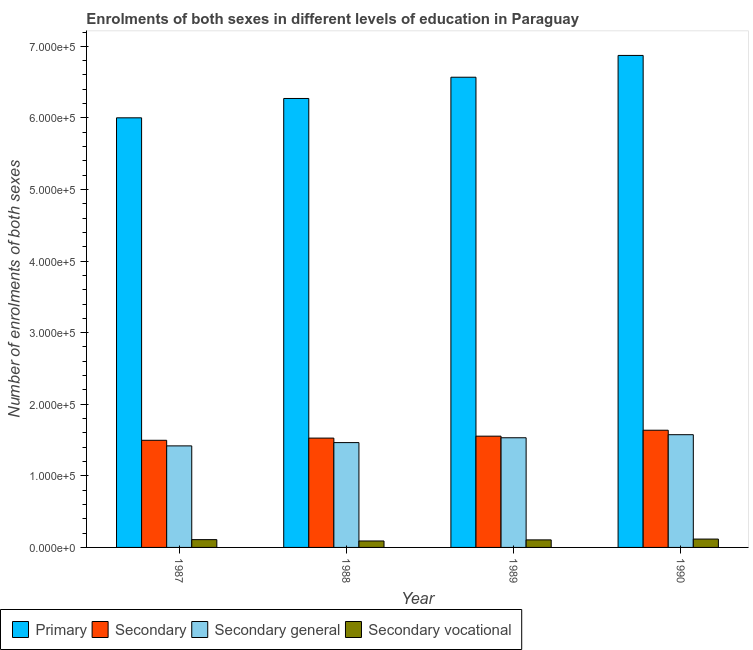How many different coloured bars are there?
Provide a succinct answer. 4. How many groups of bars are there?
Make the answer very short. 4. Are the number of bars per tick equal to the number of legend labels?
Your response must be concise. Yes. What is the label of the 1st group of bars from the left?
Make the answer very short. 1987. What is the number of enrolments in secondary vocational education in 1989?
Give a very brief answer. 1.05e+04. Across all years, what is the maximum number of enrolments in secondary general education?
Ensure brevity in your answer.  1.57e+05. Across all years, what is the minimum number of enrolments in secondary education?
Give a very brief answer. 1.50e+05. In which year was the number of enrolments in primary education maximum?
Ensure brevity in your answer.  1990. In which year was the number of enrolments in primary education minimum?
Offer a very short reply. 1987. What is the total number of enrolments in primary education in the graph?
Your answer should be very brief. 2.57e+06. What is the difference between the number of enrolments in secondary vocational education in 1989 and that in 1990?
Provide a short and direct response. -1152. What is the difference between the number of enrolments in secondary vocational education in 1988 and the number of enrolments in secondary education in 1990?
Your response must be concise. -2680. What is the average number of enrolments in secondary general education per year?
Offer a terse response. 1.50e+05. In the year 1990, what is the difference between the number of enrolments in secondary general education and number of enrolments in primary education?
Give a very brief answer. 0. What is the ratio of the number of enrolments in secondary general education in 1987 to that in 1989?
Your answer should be compact. 0.93. Is the number of enrolments in secondary vocational education in 1988 less than that in 1989?
Your answer should be very brief. Yes. Is the difference between the number of enrolments in secondary general education in 1987 and 1990 greater than the difference between the number of enrolments in secondary vocational education in 1987 and 1990?
Your answer should be very brief. No. What is the difference between the highest and the second highest number of enrolments in secondary vocational education?
Offer a terse response. 803. What is the difference between the highest and the lowest number of enrolments in primary education?
Ensure brevity in your answer.  8.72e+04. In how many years, is the number of enrolments in primary education greater than the average number of enrolments in primary education taken over all years?
Provide a short and direct response. 2. Is the sum of the number of enrolments in secondary general education in 1987 and 1989 greater than the maximum number of enrolments in secondary education across all years?
Offer a terse response. Yes. What does the 2nd bar from the left in 1989 represents?
Your response must be concise. Secondary. What does the 4th bar from the right in 1989 represents?
Offer a very short reply. Primary. Is it the case that in every year, the sum of the number of enrolments in primary education and number of enrolments in secondary education is greater than the number of enrolments in secondary general education?
Your answer should be very brief. Yes. How many bars are there?
Your response must be concise. 16. Are all the bars in the graph horizontal?
Your answer should be very brief. No. What is the difference between two consecutive major ticks on the Y-axis?
Offer a very short reply. 1.00e+05. Does the graph contain grids?
Your answer should be compact. No. How many legend labels are there?
Provide a succinct answer. 4. How are the legend labels stacked?
Your response must be concise. Horizontal. What is the title of the graph?
Provide a succinct answer. Enrolments of both sexes in different levels of education in Paraguay. What is the label or title of the Y-axis?
Give a very brief answer. Number of enrolments of both sexes. What is the Number of enrolments of both sexes in Primary in 1987?
Your response must be concise. 6.00e+05. What is the Number of enrolments of both sexes of Secondary in 1987?
Offer a very short reply. 1.50e+05. What is the Number of enrolments of both sexes of Secondary general in 1987?
Offer a very short reply. 1.42e+05. What is the Number of enrolments of both sexes in Secondary vocational in 1987?
Give a very brief answer. 1.09e+04. What is the Number of enrolments of both sexes in Primary in 1988?
Ensure brevity in your answer.  6.27e+05. What is the Number of enrolments of both sexes in Secondary in 1988?
Give a very brief answer. 1.53e+05. What is the Number of enrolments of both sexes in Secondary general in 1988?
Your answer should be compact. 1.46e+05. What is the Number of enrolments of both sexes in Secondary vocational in 1988?
Provide a short and direct response. 9000. What is the Number of enrolments of both sexes of Primary in 1989?
Your answer should be compact. 6.57e+05. What is the Number of enrolments of both sexes of Secondary in 1989?
Your answer should be very brief. 1.55e+05. What is the Number of enrolments of both sexes of Secondary general in 1989?
Offer a very short reply. 1.53e+05. What is the Number of enrolments of both sexes of Secondary vocational in 1989?
Ensure brevity in your answer.  1.05e+04. What is the Number of enrolments of both sexes of Primary in 1990?
Ensure brevity in your answer.  6.87e+05. What is the Number of enrolments of both sexes in Secondary in 1990?
Offer a terse response. 1.64e+05. What is the Number of enrolments of both sexes of Secondary general in 1990?
Your answer should be compact. 1.57e+05. What is the Number of enrolments of both sexes of Secondary vocational in 1990?
Provide a succinct answer. 1.17e+04. Across all years, what is the maximum Number of enrolments of both sexes in Primary?
Your answer should be compact. 6.87e+05. Across all years, what is the maximum Number of enrolments of both sexes in Secondary?
Ensure brevity in your answer.  1.64e+05. Across all years, what is the maximum Number of enrolments of both sexes of Secondary general?
Your answer should be compact. 1.57e+05. Across all years, what is the maximum Number of enrolments of both sexes in Secondary vocational?
Your answer should be compact. 1.17e+04. Across all years, what is the minimum Number of enrolments of both sexes in Primary?
Offer a terse response. 6.00e+05. Across all years, what is the minimum Number of enrolments of both sexes in Secondary?
Your answer should be compact. 1.50e+05. Across all years, what is the minimum Number of enrolments of both sexes of Secondary general?
Your answer should be very brief. 1.42e+05. Across all years, what is the minimum Number of enrolments of both sexes of Secondary vocational?
Provide a succinct answer. 9000. What is the total Number of enrolments of both sexes of Primary in the graph?
Provide a short and direct response. 2.57e+06. What is the total Number of enrolments of both sexes of Secondary in the graph?
Offer a terse response. 6.22e+05. What is the total Number of enrolments of both sexes in Secondary general in the graph?
Keep it short and to the point. 5.99e+05. What is the total Number of enrolments of both sexes of Secondary vocational in the graph?
Your answer should be compact. 4.21e+04. What is the difference between the Number of enrolments of both sexes of Primary in 1987 and that in 1988?
Provide a short and direct response. -2.70e+04. What is the difference between the Number of enrolments of both sexes of Secondary in 1987 and that in 1988?
Make the answer very short. -3051. What is the difference between the Number of enrolments of both sexes of Secondary general in 1987 and that in 1988?
Offer a very short reply. -4584. What is the difference between the Number of enrolments of both sexes of Secondary vocational in 1987 and that in 1988?
Give a very brief answer. 1877. What is the difference between the Number of enrolments of both sexes in Primary in 1987 and that in 1989?
Provide a succinct answer. -5.67e+04. What is the difference between the Number of enrolments of both sexes in Secondary in 1987 and that in 1989?
Provide a short and direct response. -5758. What is the difference between the Number of enrolments of both sexes of Secondary general in 1987 and that in 1989?
Provide a short and direct response. -1.14e+04. What is the difference between the Number of enrolments of both sexes of Secondary vocational in 1987 and that in 1989?
Your answer should be very brief. 349. What is the difference between the Number of enrolments of both sexes of Primary in 1987 and that in 1990?
Your answer should be very brief. -8.72e+04. What is the difference between the Number of enrolments of both sexes in Secondary in 1987 and that in 1990?
Give a very brief answer. -1.41e+04. What is the difference between the Number of enrolments of both sexes in Secondary general in 1987 and that in 1990?
Give a very brief answer. -1.56e+04. What is the difference between the Number of enrolments of both sexes of Secondary vocational in 1987 and that in 1990?
Your answer should be compact. -803. What is the difference between the Number of enrolments of both sexes of Primary in 1988 and that in 1989?
Offer a very short reply. -2.97e+04. What is the difference between the Number of enrolments of both sexes in Secondary in 1988 and that in 1989?
Your response must be concise. -2707. What is the difference between the Number of enrolments of both sexes in Secondary general in 1988 and that in 1989?
Keep it short and to the point. -6772. What is the difference between the Number of enrolments of both sexes in Secondary vocational in 1988 and that in 1989?
Give a very brief answer. -1528. What is the difference between the Number of enrolments of both sexes in Primary in 1988 and that in 1990?
Offer a very short reply. -6.01e+04. What is the difference between the Number of enrolments of both sexes of Secondary in 1988 and that in 1990?
Ensure brevity in your answer.  -1.10e+04. What is the difference between the Number of enrolments of both sexes of Secondary general in 1988 and that in 1990?
Your answer should be compact. -1.11e+04. What is the difference between the Number of enrolments of both sexes of Secondary vocational in 1988 and that in 1990?
Keep it short and to the point. -2680. What is the difference between the Number of enrolments of both sexes of Primary in 1989 and that in 1990?
Your answer should be very brief. -3.05e+04. What is the difference between the Number of enrolments of both sexes in Secondary in 1989 and that in 1990?
Your answer should be very brief. -8300. What is the difference between the Number of enrolments of both sexes in Secondary general in 1989 and that in 1990?
Your answer should be very brief. -4281. What is the difference between the Number of enrolments of both sexes in Secondary vocational in 1989 and that in 1990?
Make the answer very short. -1152. What is the difference between the Number of enrolments of both sexes of Primary in 1987 and the Number of enrolments of both sexes of Secondary in 1988?
Your answer should be compact. 4.47e+05. What is the difference between the Number of enrolments of both sexes of Primary in 1987 and the Number of enrolments of both sexes of Secondary general in 1988?
Your answer should be compact. 4.54e+05. What is the difference between the Number of enrolments of both sexes of Primary in 1987 and the Number of enrolments of both sexes of Secondary vocational in 1988?
Make the answer very short. 5.91e+05. What is the difference between the Number of enrolments of both sexes of Secondary in 1987 and the Number of enrolments of both sexes of Secondary general in 1988?
Ensure brevity in your answer.  3242. What is the difference between the Number of enrolments of both sexes of Secondary in 1987 and the Number of enrolments of both sexes of Secondary vocational in 1988?
Your response must be concise. 1.41e+05. What is the difference between the Number of enrolments of both sexes in Secondary general in 1987 and the Number of enrolments of both sexes in Secondary vocational in 1988?
Your answer should be compact. 1.33e+05. What is the difference between the Number of enrolments of both sexes in Primary in 1987 and the Number of enrolments of both sexes in Secondary in 1989?
Your answer should be compact. 4.45e+05. What is the difference between the Number of enrolments of both sexes of Primary in 1987 and the Number of enrolments of both sexes of Secondary general in 1989?
Provide a succinct answer. 4.47e+05. What is the difference between the Number of enrolments of both sexes of Primary in 1987 and the Number of enrolments of both sexes of Secondary vocational in 1989?
Your answer should be very brief. 5.90e+05. What is the difference between the Number of enrolments of both sexes in Secondary in 1987 and the Number of enrolments of both sexes in Secondary general in 1989?
Offer a terse response. -3530. What is the difference between the Number of enrolments of both sexes in Secondary in 1987 and the Number of enrolments of both sexes in Secondary vocational in 1989?
Offer a very short reply. 1.39e+05. What is the difference between the Number of enrolments of both sexes of Secondary general in 1987 and the Number of enrolments of both sexes of Secondary vocational in 1989?
Give a very brief answer. 1.31e+05. What is the difference between the Number of enrolments of both sexes in Primary in 1987 and the Number of enrolments of both sexes in Secondary in 1990?
Ensure brevity in your answer.  4.36e+05. What is the difference between the Number of enrolments of both sexes of Primary in 1987 and the Number of enrolments of both sexes of Secondary general in 1990?
Provide a short and direct response. 4.43e+05. What is the difference between the Number of enrolments of both sexes in Primary in 1987 and the Number of enrolments of both sexes in Secondary vocational in 1990?
Make the answer very short. 5.88e+05. What is the difference between the Number of enrolments of both sexes of Secondary in 1987 and the Number of enrolments of both sexes of Secondary general in 1990?
Offer a terse response. -7811. What is the difference between the Number of enrolments of both sexes in Secondary in 1987 and the Number of enrolments of both sexes in Secondary vocational in 1990?
Your answer should be very brief. 1.38e+05. What is the difference between the Number of enrolments of both sexes of Secondary general in 1987 and the Number of enrolments of both sexes of Secondary vocational in 1990?
Your response must be concise. 1.30e+05. What is the difference between the Number of enrolments of both sexes in Primary in 1988 and the Number of enrolments of both sexes in Secondary in 1989?
Provide a short and direct response. 4.72e+05. What is the difference between the Number of enrolments of both sexes of Primary in 1988 and the Number of enrolments of both sexes of Secondary general in 1989?
Give a very brief answer. 4.74e+05. What is the difference between the Number of enrolments of both sexes of Primary in 1988 and the Number of enrolments of both sexes of Secondary vocational in 1989?
Offer a terse response. 6.17e+05. What is the difference between the Number of enrolments of both sexes in Secondary in 1988 and the Number of enrolments of both sexes in Secondary general in 1989?
Your response must be concise. -479. What is the difference between the Number of enrolments of both sexes in Secondary in 1988 and the Number of enrolments of both sexes in Secondary vocational in 1989?
Give a very brief answer. 1.42e+05. What is the difference between the Number of enrolments of both sexes of Secondary general in 1988 and the Number of enrolments of both sexes of Secondary vocational in 1989?
Give a very brief answer. 1.36e+05. What is the difference between the Number of enrolments of both sexes of Primary in 1988 and the Number of enrolments of both sexes of Secondary in 1990?
Give a very brief answer. 4.63e+05. What is the difference between the Number of enrolments of both sexes in Primary in 1988 and the Number of enrolments of both sexes in Secondary general in 1990?
Give a very brief answer. 4.70e+05. What is the difference between the Number of enrolments of both sexes in Primary in 1988 and the Number of enrolments of both sexes in Secondary vocational in 1990?
Your response must be concise. 6.16e+05. What is the difference between the Number of enrolments of both sexes of Secondary in 1988 and the Number of enrolments of both sexes of Secondary general in 1990?
Give a very brief answer. -4760. What is the difference between the Number of enrolments of both sexes in Secondary in 1988 and the Number of enrolments of both sexes in Secondary vocational in 1990?
Offer a very short reply. 1.41e+05. What is the difference between the Number of enrolments of both sexes in Secondary general in 1988 and the Number of enrolments of both sexes in Secondary vocational in 1990?
Offer a terse response. 1.35e+05. What is the difference between the Number of enrolments of both sexes in Primary in 1989 and the Number of enrolments of both sexes in Secondary in 1990?
Your answer should be very brief. 4.93e+05. What is the difference between the Number of enrolments of both sexes in Primary in 1989 and the Number of enrolments of both sexes in Secondary general in 1990?
Provide a short and direct response. 4.99e+05. What is the difference between the Number of enrolments of both sexes in Primary in 1989 and the Number of enrolments of both sexes in Secondary vocational in 1990?
Your answer should be compact. 6.45e+05. What is the difference between the Number of enrolments of both sexes of Secondary in 1989 and the Number of enrolments of both sexes of Secondary general in 1990?
Your response must be concise. -2053. What is the difference between the Number of enrolments of both sexes of Secondary in 1989 and the Number of enrolments of both sexes of Secondary vocational in 1990?
Offer a terse response. 1.44e+05. What is the difference between the Number of enrolments of both sexes in Secondary general in 1989 and the Number of enrolments of both sexes in Secondary vocational in 1990?
Make the answer very short. 1.42e+05. What is the average Number of enrolments of both sexes of Primary per year?
Give a very brief answer. 6.43e+05. What is the average Number of enrolments of both sexes in Secondary per year?
Offer a very short reply. 1.55e+05. What is the average Number of enrolments of both sexes of Secondary general per year?
Your response must be concise. 1.50e+05. What is the average Number of enrolments of both sexes in Secondary vocational per year?
Your answer should be compact. 1.05e+04. In the year 1987, what is the difference between the Number of enrolments of both sexes in Primary and Number of enrolments of both sexes in Secondary?
Keep it short and to the point. 4.50e+05. In the year 1987, what is the difference between the Number of enrolments of both sexes of Primary and Number of enrolments of both sexes of Secondary general?
Provide a succinct answer. 4.58e+05. In the year 1987, what is the difference between the Number of enrolments of both sexes of Primary and Number of enrolments of both sexes of Secondary vocational?
Provide a succinct answer. 5.89e+05. In the year 1987, what is the difference between the Number of enrolments of both sexes in Secondary and Number of enrolments of both sexes in Secondary general?
Keep it short and to the point. 7826. In the year 1987, what is the difference between the Number of enrolments of both sexes in Secondary and Number of enrolments of both sexes in Secondary vocational?
Provide a short and direct response. 1.39e+05. In the year 1987, what is the difference between the Number of enrolments of both sexes in Secondary general and Number of enrolments of both sexes in Secondary vocational?
Your answer should be compact. 1.31e+05. In the year 1988, what is the difference between the Number of enrolments of both sexes in Primary and Number of enrolments of both sexes in Secondary?
Give a very brief answer. 4.74e+05. In the year 1988, what is the difference between the Number of enrolments of both sexes of Primary and Number of enrolments of both sexes of Secondary general?
Ensure brevity in your answer.  4.81e+05. In the year 1988, what is the difference between the Number of enrolments of both sexes of Primary and Number of enrolments of both sexes of Secondary vocational?
Keep it short and to the point. 6.18e+05. In the year 1988, what is the difference between the Number of enrolments of both sexes in Secondary and Number of enrolments of both sexes in Secondary general?
Offer a very short reply. 6293. In the year 1988, what is the difference between the Number of enrolments of both sexes in Secondary and Number of enrolments of both sexes in Secondary vocational?
Provide a succinct answer. 1.44e+05. In the year 1988, what is the difference between the Number of enrolments of both sexes in Secondary general and Number of enrolments of both sexes in Secondary vocational?
Provide a succinct answer. 1.37e+05. In the year 1989, what is the difference between the Number of enrolments of both sexes in Primary and Number of enrolments of both sexes in Secondary?
Your response must be concise. 5.01e+05. In the year 1989, what is the difference between the Number of enrolments of both sexes of Primary and Number of enrolments of both sexes of Secondary general?
Ensure brevity in your answer.  5.04e+05. In the year 1989, what is the difference between the Number of enrolments of both sexes of Primary and Number of enrolments of both sexes of Secondary vocational?
Provide a succinct answer. 6.46e+05. In the year 1989, what is the difference between the Number of enrolments of both sexes in Secondary and Number of enrolments of both sexes in Secondary general?
Your response must be concise. 2228. In the year 1989, what is the difference between the Number of enrolments of both sexes in Secondary and Number of enrolments of both sexes in Secondary vocational?
Ensure brevity in your answer.  1.45e+05. In the year 1989, what is the difference between the Number of enrolments of both sexes in Secondary general and Number of enrolments of both sexes in Secondary vocational?
Keep it short and to the point. 1.43e+05. In the year 1990, what is the difference between the Number of enrolments of both sexes of Primary and Number of enrolments of both sexes of Secondary?
Your answer should be very brief. 5.24e+05. In the year 1990, what is the difference between the Number of enrolments of both sexes in Primary and Number of enrolments of both sexes in Secondary general?
Provide a short and direct response. 5.30e+05. In the year 1990, what is the difference between the Number of enrolments of both sexes in Primary and Number of enrolments of both sexes in Secondary vocational?
Your answer should be compact. 6.76e+05. In the year 1990, what is the difference between the Number of enrolments of both sexes of Secondary and Number of enrolments of both sexes of Secondary general?
Offer a very short reply. 6247. In the year 1990, what is the difference between the Number of enrolments of both sexes of Secondary and Number of enrolments of both sexes of Secondary vocational?
Your answer should be compact. 1.52e+05. In the year 1990, what is the difference between the Number of enrolments of both sexes in Secondary general and Number of enrolments of both sexes in Secondary vocational?
Make the answer very short. 1.46e+05. What is the ratio of the Number of enrolments of both sexes in Primary in 1987 to that in 1988?
Ensure brevity in your answer.  0.96. What is the ratio of the Number of enrolments of both sexes in Secondary in 1987 to that in 1988?
Your answer should be very brief. 0.98. What is the ratio of the Number of enrolments of both sexes in Secondary general in 1987 to that in 1988?
Provide a succinct answer. 0.97. What is the ratio of the Number of enrolments of both sexes of Secondary vocational in 1987 to that in 1988?
Give a very brief answer. 1.21. What is the ratio of the Number of enrolments of both sexes of Primary in 1987 to that in 1989?
Make the answer very short. 0.91. What is the ratio of the Number of enrolments of both sexes in Secondary in 1987 to that in 1989?
Your answer should be compact. 0.96. What is the ratio of the Number of enrolments of both sexes of Secondary general in 1987 to that in 1989?
Your answer should be very brief. 0.93. What is the ratio of the Number of enrolments of both sexes in Secondary vocational in 1987 to that in 1989?
Ensure brevity in your answer.  1.03. What is the ratio of the Number of enrolments of both sexes of Primary in 1987 to that in 1990?
Provide a short and direct response. 0.87. What is the ratio of the Number of enrolments of both sexes in Secondary in 1987 to that in 1990?
Give a very brief answer. 0.91. What is the ratio of the Number of enrolments of both sexes in Secondary general in 1987 to that in 1990?
Offer a very short reply. 0.9. What is the ratio of the Number of enrolments of both sexes in Secondary vocational in 1987 to that in 1990?
Your response must be concise. 0.93. What is the ratio of the Number of enrolments of both sexes of Primary in 1988 to that in 1989?
Provide a succinct answer. 0.95. What is the ratio of the Number of enrolments of both sexes in Secondary in 1988 to that in 1989?
Keep it short and to the point. 0.98. What is the ratio of the Number of enrolments of both sexes of Secondary general in 1988 to that in 1989?
Offer a very short reply. 0.96. What is the ratio of the Number of enrolments of both sexes in Secondary vocational in 1988 to that in 1989?
Provide a succinct answer. 0.85. What is the ratio of the Number of enrolments of both sexes of Primary in 1988 to that in 1990?
Keep it short and to the point. 0.91. What is the ratio of the Number of enrolments of both sexes in Secondary in 1988 to that in 1990?
Offer a terse response. 0.93. What is the ratio of the Number of enrolments of both sexes of Secondary general in 1988 to that in 1990?
Your response must be concise. 0.93. What is the ratio of the Number of enrolments of both sexes in Secondary vocational in 1988 to that in 1990?
Offer a terse response. 0.77. What is the ratio of the Number of enrolments of both sexes of Primary in 1989 to that in 1990?
Provide a succinct answer. 0.96. What is the ratio of the Number of enrolments of both sexes in Secondary in 1989 to that in 1990?
Keep it short and to the point. 0.95. What is the ratio of the Number of enrolments of both sexes of Secondary general in 1989 to that in 1990?
Offer a very short reply. 0.97. What is the ratio of the Number of enrolments of both sexes in Secondary vocational in 1989 to that in 1990?
Offer a terse response. 0.9. What is the difference between the highest and the second highest Number of enrolments of both sexes in Primary?
Provide a short and direct response. 3.05e+04. What is the difference between the highest and the second highest Number of enrolments of both sexes of Secondary?
Provide a succinct answer. 8300. What is the difference between the highest and the second highest Number of enrolments of both sexes in Secondary general?
Provide a succinct answer. 4281. What is the difference between the highest and the second highest Number of enrolments of both sexes of Secondary vocational?
Give a very brief answer. 803. What is the difference between the highest and the lowest Number of enrolments of both sexes in Primary?
Provide a succinct answer. 8.72e+04. What is the difference between the highest and the lowest Number of enrolments of both sexes in Secondary?
Make the answer very short. 1.41e+04. What is the difference between the highest and the lowest Number of enrolments of both sexes in Secondary general?
Ensure brevity in your answer.  1.56e+04. What is the difference between the highest and the lowest Number of enrolments of both sexes in Secondary vocational?
Ensure brevity in your answer.  2680. 